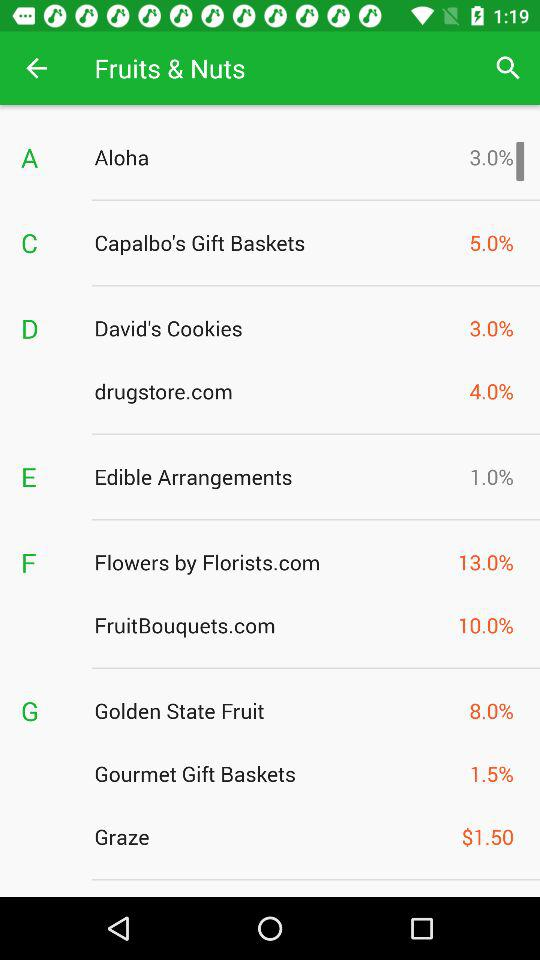What is the percentage of Aloha?
Answer the question using a single word or phrase. Aloha is 3%. 